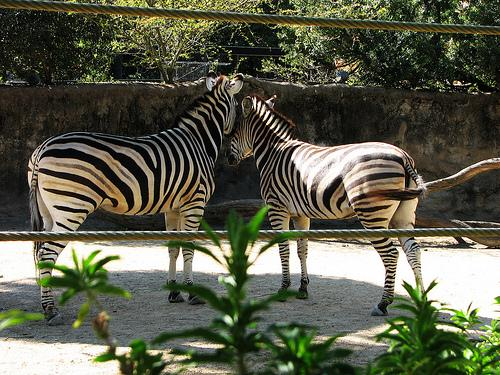Question: what colors are the zebra?
Choices:
A. Milticolored.
B. Black, white.
C. Striped.
D. Grey.
Answer with the letter. Answer: B Question: what animal is shown?
Choices:
A. Elephant.
B. Giraffe.
C. Hippo.
D. Zebra.
Answer with the letter. Answer: D Question: what pattern is the animals?
Choices:
A. Stripes.
B. Solid.
C. Spots.
D. None.
Answer with the letter. Answer: A Question: where is this shot?
Choices:
A. Safari.
B. Jungle.
C. Rain forest.
D. Zoo.
Answer with the letter. Answer: D Question: how many zebra are there?
Choices:
A. 5.
B. 4.
C. 2.
D. 3.
Answer with the letter. Answer: C Question: how many people are shown?
Choices:
A. 5.
B. 3.
C. 0.
D. 2.
Answer with the letter. Answer: C Question: how many hoofs can be seen?
Choices:
A. 4.
B. 7.
C. 9.
D. 6.
Answer with the letter. Answer: D 